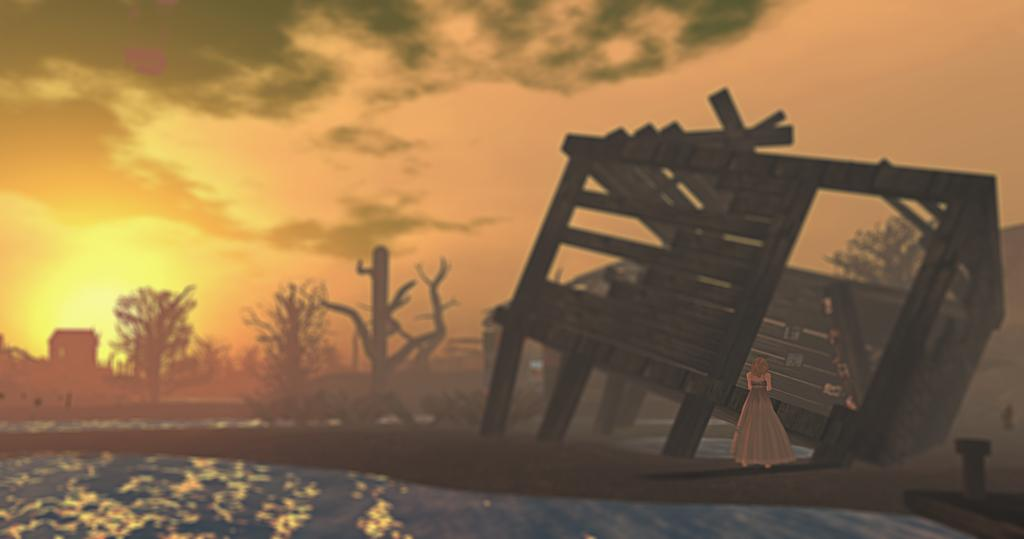What type of image is being described? The image is an animated picture. What can be seen in the image that has been damaged? There is a collapsed house in the image. Is there a person present in the image? Yes, there is a person standing in the image. What type of natural environment is visible in the image? There are trees in the image. What is visible in the background of the image? The sky is visible in the image. What type of shop can be seen in the image? There is no shop present in the image; it features a collapsed house, presumably residential, house. What nation is represented by the person standing in the image? The image does not provide any information about the nationality of the person standing in the image. 